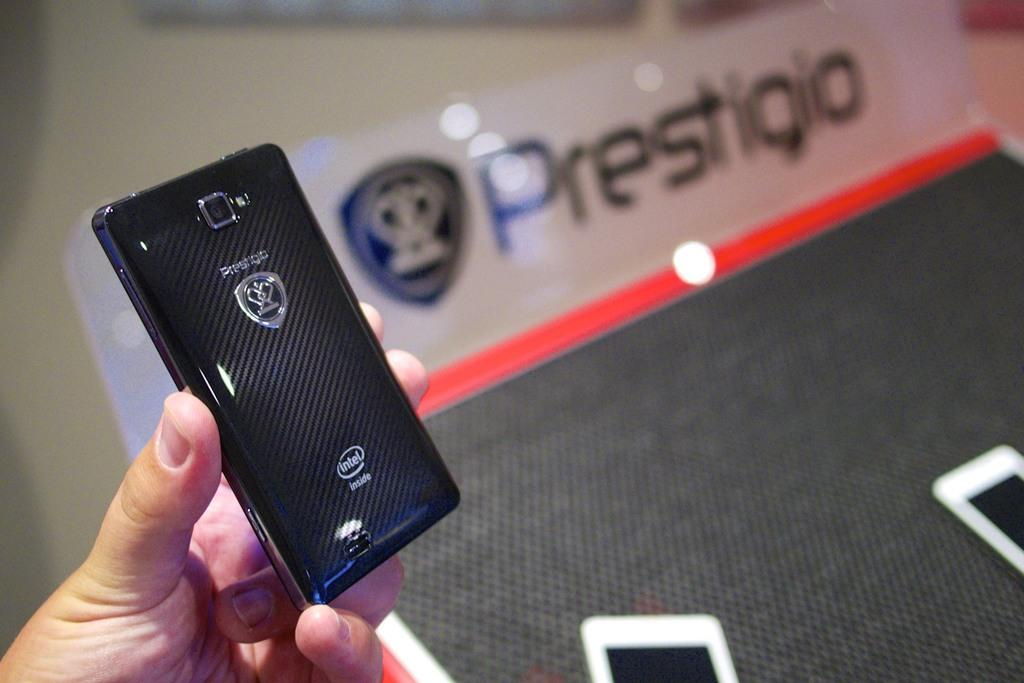Provide a one-sentence caption for the provided image. A black electronic device bears the name Prestigio. 